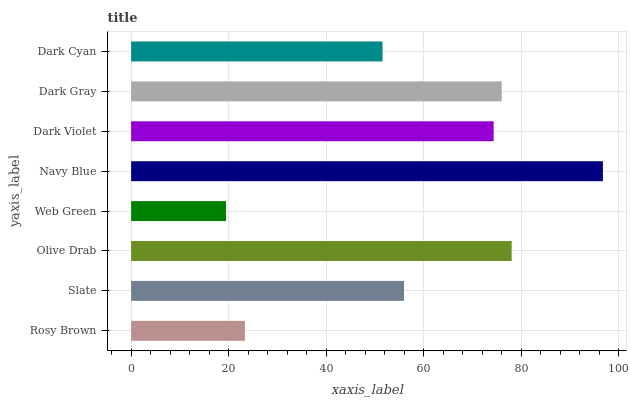Is Web Green the minimum?
Answer yes or no. Yes. Is Navy Blue the maximum?
Answer yes or no. Yes. Is Slate the minimum?
Answer yes or no. No. Is Slate the maximum?
Answer yes or no. No. Is Slate greater than Rosy Brown?
Answer yes or no. Yes. Is Rosy Brown less than Slate?
Answer yes or no. Yes. Is Rosy Brown greater than Slate?
Answer yes or no. No. Is Slate less than Rosy Brown?
Answer yes or no. No. Is Dark Violet the high median?
Answer yes or no. Yes. Is Slate the low median?
Answer yes or no. Yes. Is Dark Gray the high median?
Answer yes or no. No. Is Dark Violet the low median?
Answer yes or no. No. 